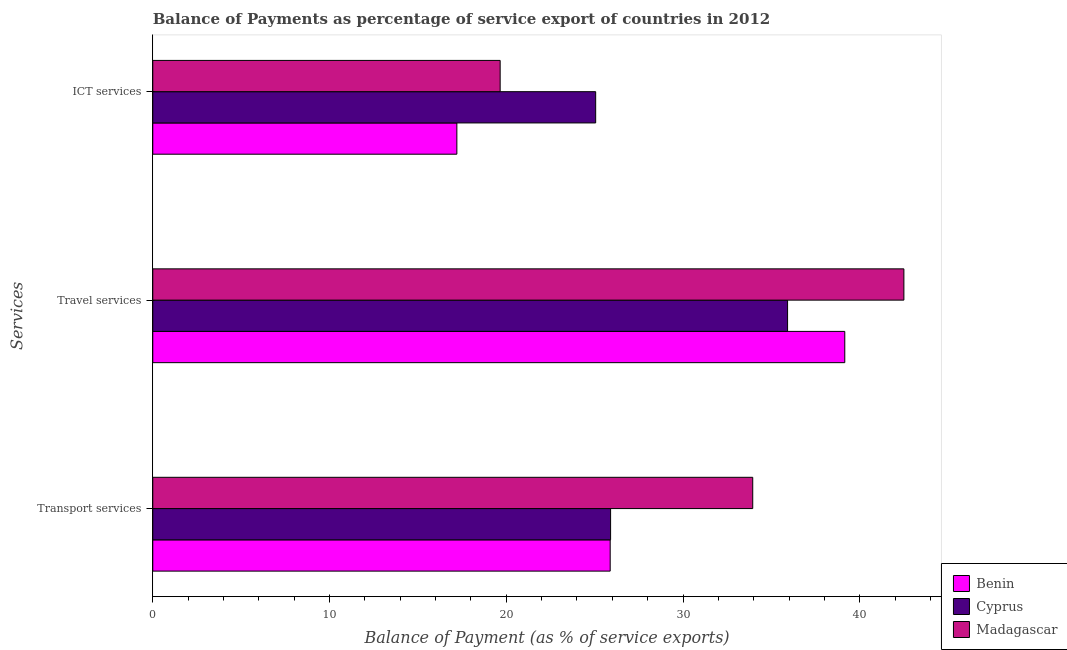How many different coloured bars are there?
Provide a short and direct response. 3. How many groups of bars are there?
Offer a very short reply. 3. Are the number of bars on each tick of the Y-axis equal?
Your answer should be compact. Yes. How many bars are there on the 1st tick from the top?
Offer a very short reply. 3. What is the label of the 1st group of bars from the top?
Give a very brief answer. ICT services. What is the balance of payment of travel services in Cyprus?
Your response must be concise. 35.91. Across all countries, what is the maximum balance of payment of ict services?
Give a very brief answer. 25.06. Across all countries, what is the minimum balance of payment of transport services?
Your answer should be compact. 25.88. In which country was the balance of payment of ict services maximum?
Give a very brief answer. Cyprus. In which country was the balance of payment of travel services minimum?
Your answer should be very brief. Cyprus. What is the total balance of payment of transport services in the graph?
Your answer should be compact. 85.72. What is the difference between the balance of payment of travel services in Benin and that in Cyprus?
Offer a very short reply. 3.24. What is the difference between the balance of payment of ict services in Benin and the balance of payment of travel services in Madagascar?
Provide a succinct answer. -25.29. What is the average balance of payment of ict services per country?
Your response must be concise. 20.64. What is the difference between the balance of payment of travel services and balance of payment of transport services in Benin?
Your response must be concise. 13.27. In how many countries, is the balance of payment of travel services greater than 38 %?
Give a very brief answer. 2. What is the ratio of the balance of payment of ict services in Cyprus to that in Benin?
Your answer should be very brief. 1.46. What is the difference between the highest and the second highest balance of payment of transport services?
Your answer should be compact. 8.04. What is the difference between the highest and the lowest balance of payment of ict services?
Offer a terse response. 7.85. In how many countries, is the balance of payment of transport services greater than the average balance of payment of transport services taken over all countries?
Ensure brevity in your answer.  1. Is the sum of the balance of payment of ict services in Cyprus and Madagascar greater than the maximum balance of payment of travel services across all countries?
Your answer should be compact. Yes. What does the 1st bar from the top in ICT services represents?
Make the answer very short. Madagascar. What does the 2nd bar from the bottom in ICT services represents?
Provide a short and direct response. Cyprus. Is it the case that in every country, the sum of the balance of payment of transport services and balance of payment of travel services is greater than the balance of payment of ict services?
Keep it short and to the point. Yes. How many bars are there?
Your response must be concise. 9. How many countries are there in the graph?
Give a very brief answer. 3. What is the difference between two consecutive major ticks on the X-axis?
Keep it short and to the point. 10. Does the graph contain any zero values?
Offer a terse response. No. Where does the legend appear in the graph?
Ensure brevity in your answer.  Bottom right. How are the legend labels stacked?
Your response must be concise. Vertical. What is the title of the graph?
Give a very brief answer. Balance of Payments as percentage of service export of countries in 2012. What is the label or title of the X-axis?
Give a very brief answer. Balance of Payment (as % of service exports). What is the label or title of the Y-axis?
Make the answer very short. Services. What is the Balance of Payment (as % of service exports) of Benin in Transport services?
Your answer should be compact. 25.88. What is the Balance of Payment (as % of service exports) of Cyprus in Transport services?
Give a very brief answer. 25.9. What is the Balance of Payment (as % of service exports) of Madagascar in Transport services?
Offer a very short reply. 33.94. What is the Balance of Payment (as % of service exports) in Benin in Travel services?
Your answer should be very brief. 39.15. What is the Balance of Payment (as % of service exports) in Cyprus in Travel services?
Make the answer very short. 35.91. What is the Balance of Payment (as % of service exports) of Madagascar in Travel services?
Your answer should be very brief. 42.5. What is the Balance of Payment (as % of service exports) of Benin in ICT services?
Your answer should be very brief. 17.2. What is the Balance of Payment (as % of service exports) of Cyprus in ICT services?
Your answer should be compact. 25.06. What is the Balance of Payment (as % of service exports) of Madagascar in ICT services?
Your answer should be very brief. 19.65. Across all Services, what is the maximum Balance of Payment (as % of service exports) in Benin?
Keep it short and to the point. 39.15. Across all Services, what is the maximum Balance of Payment (as % of service exports) of Cyprus?
Your answer should be very brief. 35.91. Across all Services, what is the maximum Balance of Payment (as % of service exports) of Madagascar?
Your answer should be compact. 42.5. Across all Services, what is the minimum Balance of Payment (as % of service exports) of Benin?
Your answer should be compact. 17.2. Across all Services, what is the minimum Balance of Payment (as % of service exports) in Cyprus?
Provide a succinct answer. 25.06. Across all Services, what is the minimum Balance of Payment (as % of service exports) in Madagascar?
Your response must be concise. 19.65. What is the total Balance of Payment (as % of service exports) of Benin in the graph?
Provide a short and direct response. 82.23. What is the total Balance of Payment (as % of service exports) of Cyprus in the graph?
Offer a very short reply. 86.87. What is the total Balance of Payment (as % of service exports) of Madagascar in the graph?
Your answer should be very brief. 96.09. What is the difference between the Balance of Payment (as % of service exports) in Benin in Transport services and that in Travel services?
Ensure brevity in your answer.  -13.27. What is the difference between the Balance of Payment (as % of service exports) of Cyprus in Transport services and that in Travel services?
Ensure brevity in your answer.  -10.01. What is the difference between the Balance of Payment (as % of service exports) of Madagascar in Transport services and that in Travel services?
Your answer should be very brief. -8.55. What is the difference between the Balance of Payment (as % of service exports) of Benin in Transport services and that in ICT services?
Give a very brief answer. 8.68. What is the difference between the Balance of Payment (as % of service exports) in Cyprus in Transport services and that in ICT services?
Provide a succinct answer. 0.84. What is the difference between the Balance of Payment (as % of service exports) of Madagascar in Transport services and that in ICT services?
Keep it short and to the point. 14.29. What is the difference between the Balance of Payment (as % of service exports) in Benin in Travel services and that in ICT services?
Give a very brief answer. 21.95. What is the difference between the Balance of Payment (as % of service exports) in Cyprus in Travel services and that in ICT services?
Ensure brevity in your answer.  10.86. What is the difference between the Balance of Payment (as % of service exports) of Madagascar in Travel services and that in ICT services?
Give a very brief answer. 22.84. What is the difference between the Balance of Payment (as % of service exports) of Benin in Transport services and the Balance of Payment (as % of service exports) of Cyprus in Travel services?
Your answer should be compact. -10.04. What is the difference between the Balance of Payment (as % of service exports) of Benin in Transport services and the Balance of Payment (as % of service exports) of Madagascar in Travel services?
Your answer should be compact. -16.62. What is the difference between the Balance of Payment (as % of service exports) in Cyprus in Transport services and the Balance of Payment (as % of service exports) in Madagascar in Travel services?
Provide a succinct answer. -16.59. What is the difference between the Balance of Payment (as % of service exports) of Benin in Transport services and the Balance of Payment (as % of service exports) of Cyprus in ICT services?
Offer a terse response. 0.82. What is the difference between the Balance of Payment (as % of service exports) in Benin in Transport services and the Balance of Payment (as % of service exports) in Madagascar in ICT services?
Offer a terse response. 6.23. What is the difference between the Balance of Payment (as % of service exports) of Cyprus in Transport services and the Balance of Payment (as % of service exports) of Madagascar in ICT services?
Provide a short and direct response. 6.25. What is the difference between the Balance of Payment (as % of service exports) of Benin in Travel services and the Balance of Payment (as % of service exports) of Cyprus in ICT services?
Provide a short and direct response. 14.09. What is the difference between the Balance of Payment (as % of service exports) in Benin in Travel services and the Balance of Payment (as % of service exports) in Madagascar in ICT services?
Ensure brevity in your answer.  19.5. What is the difference between the Balance of Payment (as % of service exports) of Cyprus in Travel services and the Balance of Payment (as % of service exports) of Madagascar in ICT services?
Your answer should be very brief. 16.26. What is the average Balance of Payment (as % of service exports) of Benin per Services?
Offer a very short reply. 27.41. What is the average Balance of Payment (as % of service exports) of Cyprus per Services?
Make the answer very short. 28.96. What is the average Balance of Payment (as % of service exports) of Madagascar per Services?
Give a very brief answer. 32.03. What is the difference between the Balance of Payment (as % of service exports) in Benin and Balance of Payment (as % of service exports) in Cyprus in Transport services?
Your response must be concise. -0.02. What is the difference between the Balance of Payment (as % of service exports) of Benin and Balance of Payment (as % of service exports) of Madagascar in Transport services?
Provide a succinct answer. -8.06. What is the difference between the Balance of Payment (as % of service exports) of Cyprus and Balance of Payment (as % of service exports) of Madagascar in Transport services?
Your response must be concise. -8.04. What is the difference between the Balance of Payment (as % of service exports) in Benin and Balance of Payment (as % of service exports) in Cyprus in Travel services?
Make the answer very short. 3.24. What is the difference between the Balance of Payment (as % of service exports) of Benin and Balance of Payment (as % of service exports) of Madagascar in Travel services?
Your answer should be very brief. -3.34. What is the difference between the Balance of Payment (as % of service exports) of Cyprus and Balance of Payment (as % of service exports) of Madagascar in Travel services?
Your response must be concise. -6.58. What is the difference between the Balance of Payment (as % of service exports) of Benin and Balance of Payment (as % of service exports) of Cyprus in ICT services?
Provide a succinct answer. -7.85. What is the difference between the Balance of Payment (as % of service exports) in Benin and Balance of Payment (as % of service exports) in Madagascar in ICT services?
Provide a succinct answer. -2.45. What is the difference between the Balance of Payment (as % of service exports) of Cyprus and Balance of Payment (as % of service exports) of Madagascar in ICT services?
Keep it short and to the point. 5.4. What is the ratio of the Balance of Payment (as % of service exports) of Benin in Transport services to that in Travel services?
Your response must be concise. 0.66. What is the ratio of the Balance of Payment (as % of service exports) in Cyprus in Transport services to that in Travel services?
Offer a terse response. 0.72. What is the ratio of the Balance of Payment (as % of service exports) in Madagascar in Transport services to that in Travel services?
Make the answer very short. 0.8. What is the ratio of the Balance of Payment (as % of service exports) of Benin in Transport services to that in ICT services?
Your answer should be compact. 1.5. What is the ratio of the Balance of Payment (as % of service exports) in Cyprus in Transport services to that in ICT services?
Your answer should be compact. 1.03. What is the ratio of the Balance of Payment (as % of service exports) in Madagascar in Transport services to that in ICT services?
Make the answer very short. 1.73. What is the ratio of the Balance of Payment (as % of service exports) of Benin in Travel services to that in ICT services?
Give a very brief answer. 2.28. What is the ratio of the Balance of Payment (as % of service exports) of Cyprus in Travel services to that in ICT services?
Make the answer very short. 1.43. What is the ratio of the Balance of Payment (as % of service exports) in Madagascar in Travel services to that in ICT services?
Keep it short and to the point. 2.16. What is the difference between the highest and the second highest Balance of Payment (as % of service exports) of Benin?
Offer a very short reply. 13.27. What is the difference between the highest and the second highest Balance of Payment (as % of service exports) in Cyprus?
Provide a succinct answer. 10.01. What is the difference between the highest and the second highest Balance of Payment (as % of service exports) in Madagascar?
Your answer should be very brief. 8.55. What is the difference between the highest and the lowest Balance of Payment (as % of service exports) in Benin?
Give a very brief answer. 21.95. What is the difference between the highest and the lowest Balance of Payment (as % of service exports) of Cyprus?
Your answer should be very brief. 10.86. What is the difference between the highest and the lowest Balance of Payment (as % of service exports) of Madagascar?
Your response must be concise. 22.84. 